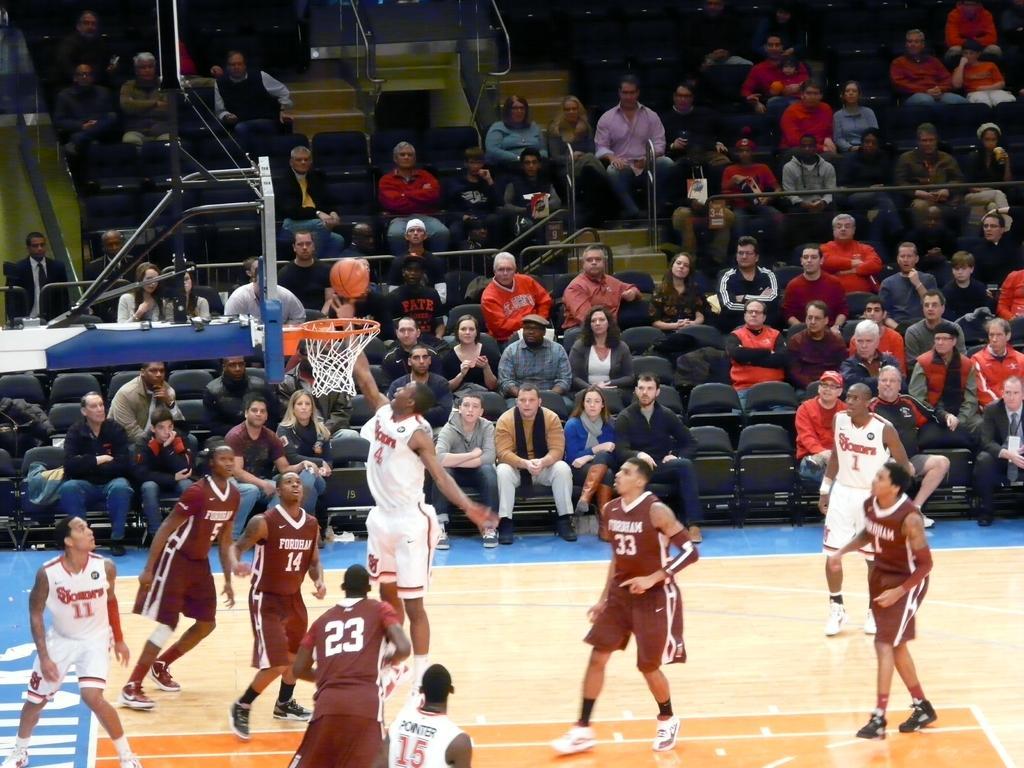Could you give a brief overview of what you see in this image? In this image I can see number of people were few of them are playing basketball and rest all are sitting on chairs. In the front of the image I can see few people are wearing sports jerseys and on their jerseys I can see something is written. On the left side of the image I can see a basketball net, a board and a basketball in the air. 